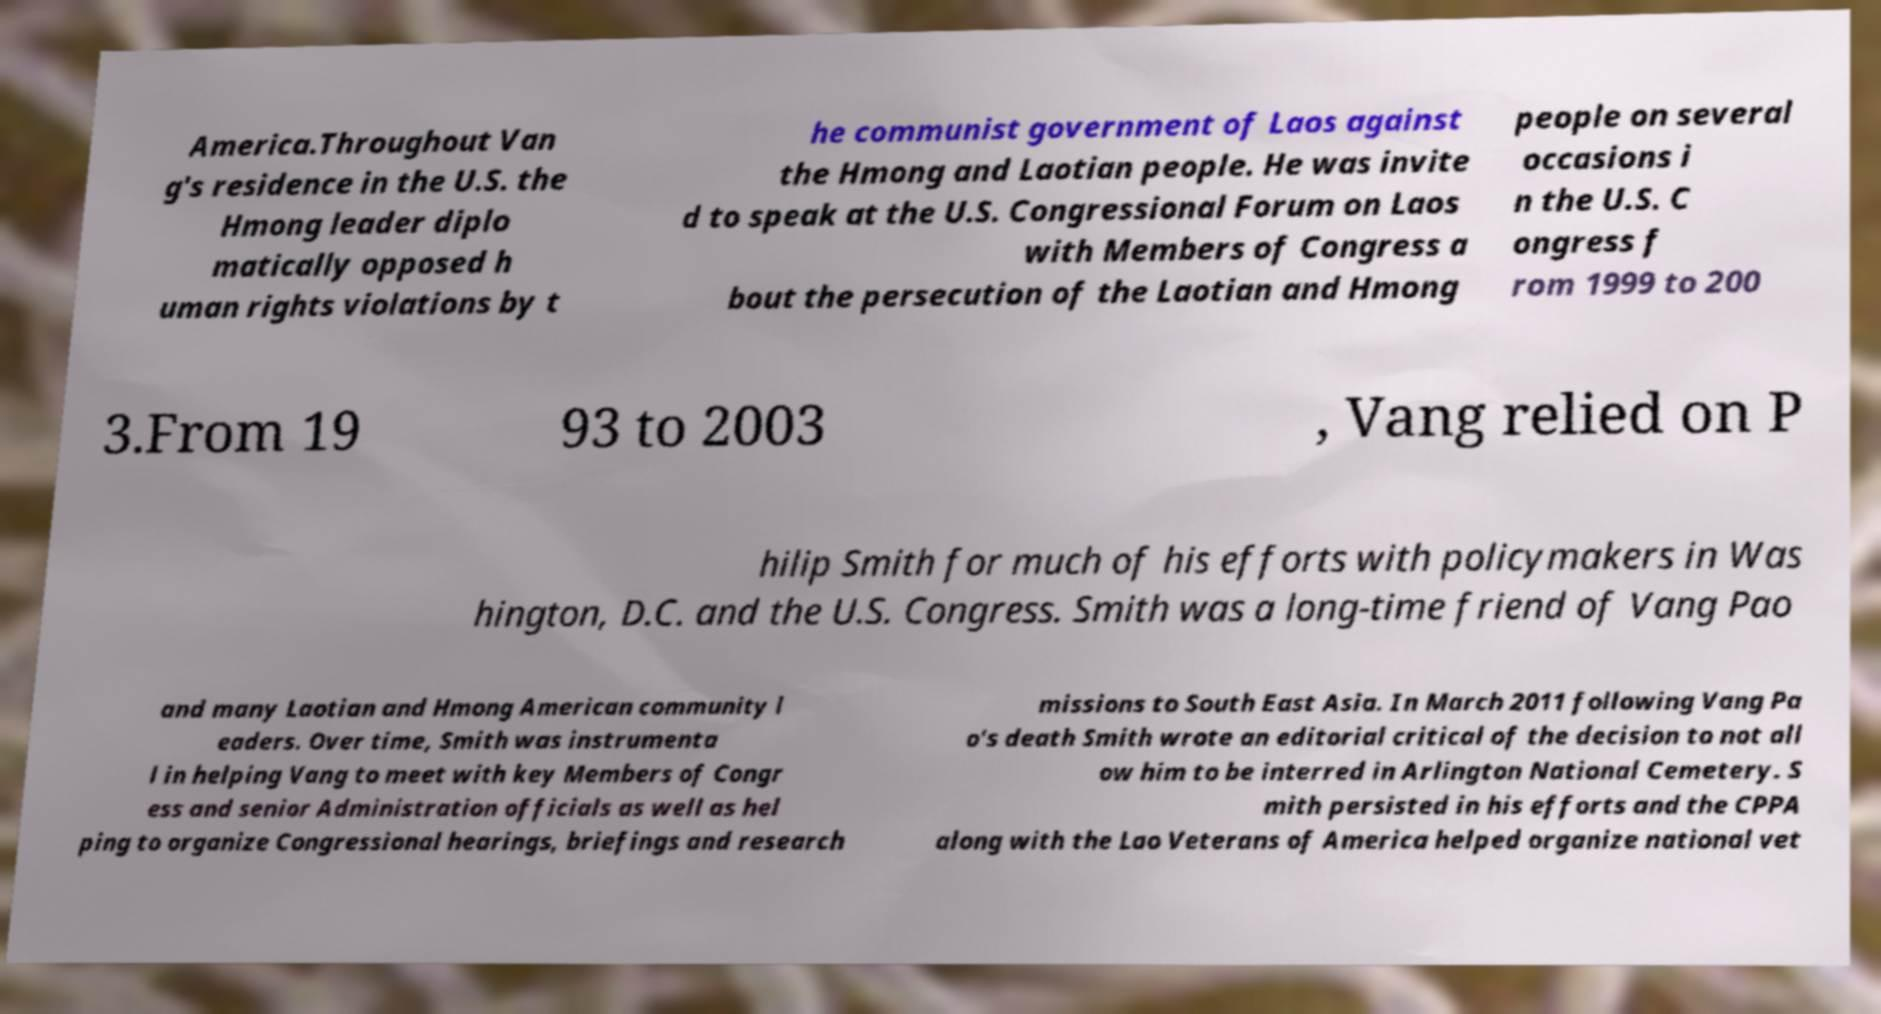There's text embedded in this image that I need extracted. Can you transcribe it verbatim? America.Throughout Van g's residence in the U.S. the Hmong leader diplo matically opposed h uman rights violations by t he communist government of Laos against the Hmong and Laotian people. He was invite d to speak at the U.S. Congressional Forum on Laos with Members of Congress a bout the persecution of the Laotian and Hmong people on several occasions i n the U.S. C ongress f rom 1999 to 200 3.From 19 93 to 2003 , Vang relied on P hilip Smith for much of his efforts with policymakers in Was hington, D.C. and the U.S. Congress. Smith was a long-time friend of Vang Pao and many Laotian and Hmong American community l eaders. Over time, Smith was instrumenta l in helping Vang to meet with key Members of Congr ess and senior Administration officials as well as hel ping to organize Congressional hearings, briefings and research missions to South East Asia. In March 2011 following Vang Pa o's death Smith wrote an editorial critical of the decision to not all ow him to be interred in Arlington National Cemetery. S mith persisted in his efforts and the CPPA along with the Lao Veterans of America helped organize national vet 